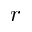Convert formula to latex. <formula><loc_0><loc_0><loc_500><loc_500>r</formula> 